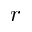Convert formula to latex. <formula><loc_0><loc_0><loc_500><loc_500>r</formula> 